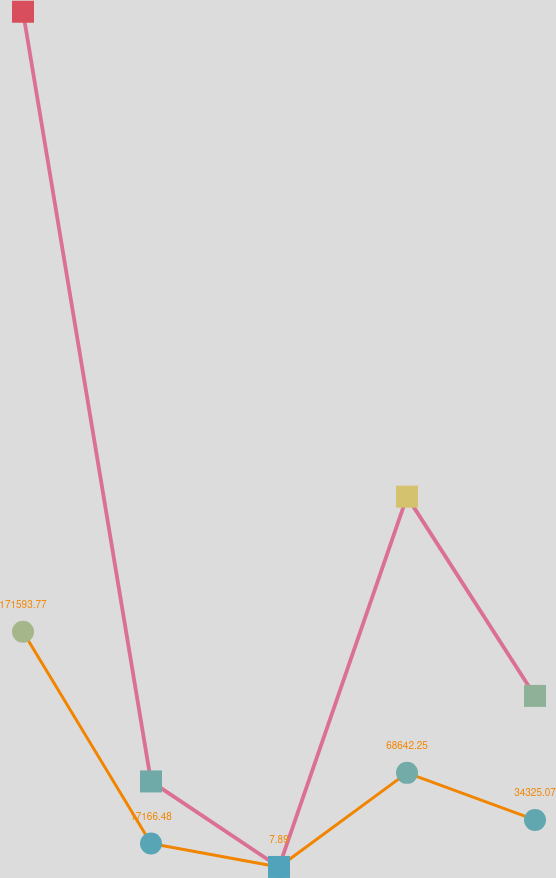<chart> <loc_0><loc_0><loc_500><loc_500><line_chart><ecel><fcel>Aviation<fcel>Total<nl><fcel>32.27<fcel>171594<fcel>623626<nl><fcel>63261.7<fcel>17166.5<fcel>62392.2<nl><fcel>126491<fcel>7.89<fcel>32.91<nl><fcel>189721<fcel>68642.2<fcel>270071<nl><fcel>252950<fcel>34325.1<fcel>124752<nl><fcel>632327<fcel>51483.7<fcel>187111<nl></chart> 